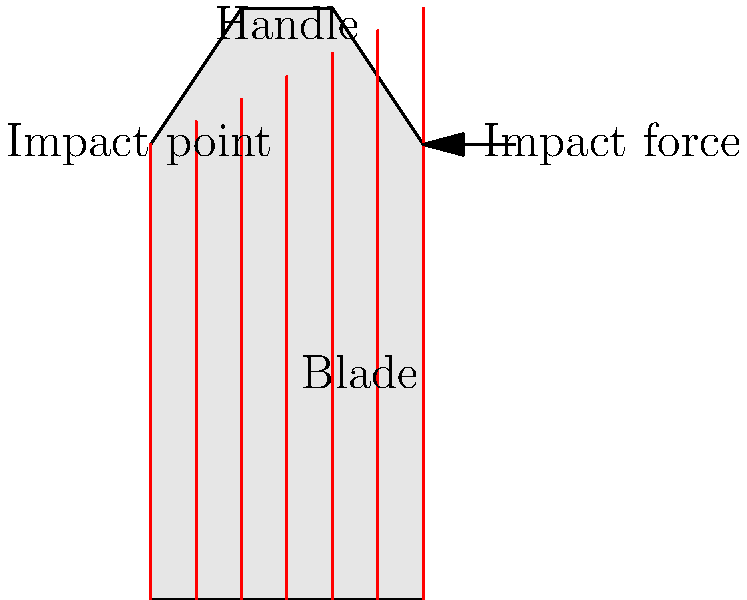In a cricket bat, where is the stress concentration likely to be highest during impact with the ball, and why is this important for bat design? To understand the stress distribution in a cricket bat during impact, we need to consider the following steps:

1. Bat structure: A cricket bat consists of two main parts - the handle and the blade. The handle is typically made of cane, while the blade is made of willow.

2. Impact point: When a ball strikes the bat, it usually hits the blade near the top, creating an impact force.

3. Stress distribution:
   a) The impact force creates a bending moment in the bat.
   b) This bending moment generates compressive stress on the impact side and tensile stress on the opposite side.
   c) The stress is distributed along the length of the bat, with the highest concentration at the junction between the handle and the blade.

4. Stress concentration: The junction between the handle and blade experiences the highest stress concentration because:
   a) There is a sudden change in cross-sectional area.
   b) There's a transition between different materials (cane to willow).
   c) The bending moment is maximum at this point.

5. Importance in bat design:
   a) Knowing the high-stress area helps in reinforcing that part of the bat.
   b) It guides the selection of materials and manufacturing processes.
   c) It influences the overall bat shape and weight distribution.
   d) Understanding stress distribution helps in optimizing the bat's performance and durability.

The stress concentration at the handle-blade junction is crucial because it's the most likely point of failure during intense impacts. Proper design considerations at this point can significantly improve the bat's lifespan and performance.
Answer: Handle-blade junction, crucial for bat durability and performance optimization. 